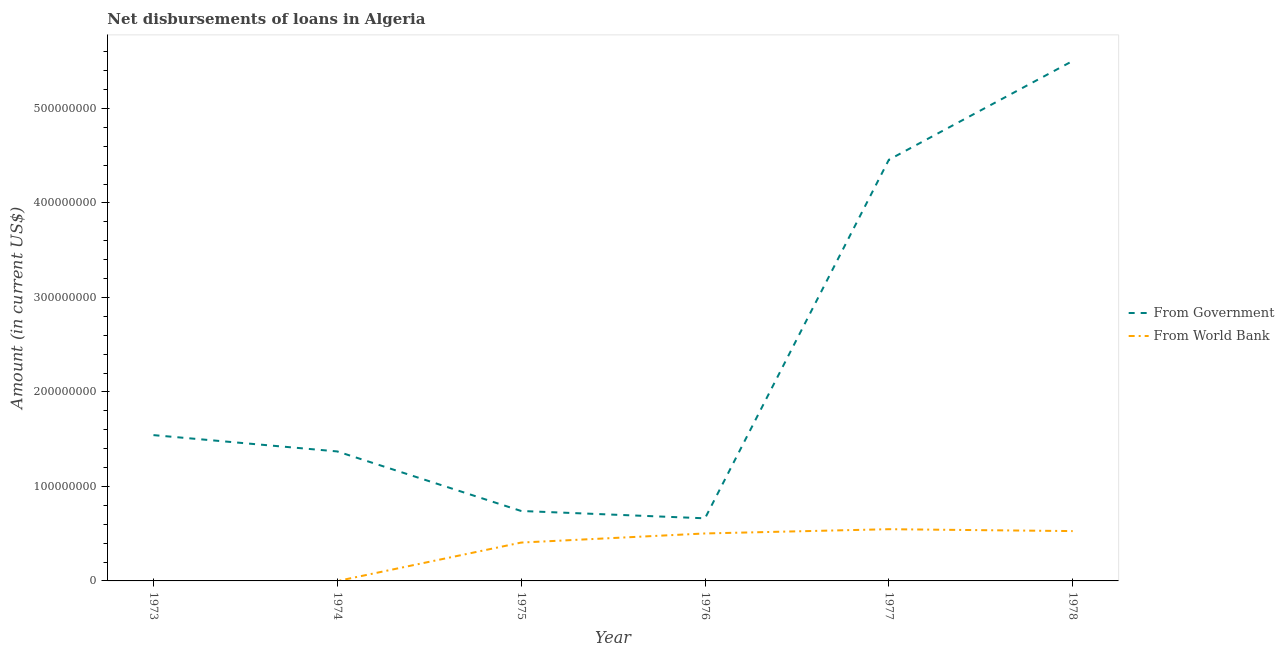How many different coloured lines are there?
Your answer should be very brief. 2. Is the number of lines equal to the number of legend labels?
Your response must be concise. No. What is the net disbursements of loan from world bank in 1976?
Keep it short and to the point. 5.02e+07. Across all years, what is the maximum net disbursements of loan from world bank?
Your response must be concise. 5.47e+07. Across all years, what is the minimum net disbursements of loan from world bank?
Offer a terse response. 0. What is the total net disbursements of loan from world bank in the graph?
Your response must be concise. 1.98e+08. What is the difference between the net disbursements of loan from government in 1973 and that in 1974?
Offer a terse response. 1.73e+07. What is the difference between the net disbursements of loan from government in 1975 and the net disbursements of loan from world bank in 1978?
Give a very brief answer. 2.13e+07. What is the average net disbursements of loan from world bank per year?
Offer a terse response. 3.30e+07. In the year 1975, what is the difference between the net disbursements of loan from government and net disbursements of loan from world bank?
Give a very brief answer. 3.34e+07. In how many years, is the net disbursements of loan from world bank greater than 360000000 US$?
Make the answer very short. 0. What is the ratio of the net disbursements of loan from world bank in 1975 to that in 1978?
Your response must be concise. 0.77. Is the net disbursements of loan from government in 1973 less than that in 1974?
Ensure brevity in your answer.  No. What is the difference between the highest and the second highest net disbursements of loan from world bank?
Make the answer very short. 2.00e+06. What is the difference between the highest and the lowest net disbursements of loan from government?
Your answer should be very brief. 4.84e+08. In how many years, is the net disbursements of loan from world bank greater than the average net disbursements of loan from world bank taken over all years?
Offer a very short reply. 4. Does the net disbursements of loan from world bank monotonically increase over the years?
Offer a terse response. No. Is the net disbursements of loan from world bank strictly greater than the net disbursements of loan from government over the years?
Your answer should be compact. No. Is the net disbursements of loan from government strictly less than the net disbursements of loan from world bank over the years?
Give a very brief answer. No. Are the values on the major ticks of Y-axis written in scientific E-notation?
Make the answer very short. No. Does the graph contain any zero values?
Your answer should be very brief. Yes. How many legend labels are there?
Your response must be concise. 2. What is the title of the graph?
Offer a terse response. Net disbursements of loans in Algeria. Does "Health Care" appear as one of the legend labels in the graph?
Offer a terse response. No. What is the Amount (in current US$) of From Government in 1973?
Give a very brief answer. 1.54e+08. What is the Amount (in current US$) of From World Bank in 1973?
Keep it short and to the point. 0. What is the Amount (in current US$) in From Government in 1974?
Offer a very short reply. 1.37e+08. What is the Amount (in current US$) of From Government in 1975?
Provide a short and direct response. 7.40e+07. What is the Amount (in current US$) in From World Bank in 1975?
Keep it short and to the point. 4.06e+07. What is the Amount (in current US$) of From Government in 1976?
Your answer should be very brief. 6.63e+07. What is the Amount (in current US$) in From World Bank in 1976?
Your response must be concise. 5.02e+07. What is the Amount (in current US$) in From Government in 1977?
Offer a very short reply. 4.46e+08. What is the Amount (in current US$) of From World Bank in 1977?
Give a very brief answer. 5.47e+07. What is the Amount (in current US$) in From Government in 1978?
Make the answer very short. 5.50e+08. What is the Amount (in current US$) in From World Bank in 1978?
Provide a short and direct response. 5.27e+07. Across all years, what is the maximum Amount (in current US$) in From Government?
Offer a very short reply. 5.50e+08. Across all years, what is the maximum Amount (in current US$) in From World Bank?
Offer a terse response. 5.47e+07. Across all years, what is the minimum Amount (in current US$) of From Government?
Keep it short and to the point. 6.63e+07. What is the total Amount (in current US$) in From Government in the graph?
Offer a terse response. 1.43e+09. What is the total Amount (in current US$) of From World Bank in the graph?
Offer a very short reply. 1.98e+08. What is the difference between the Amount (in current US$) in From Government in 1973 and that in 1974?
Offer a very short reply. 1.73e+07. What is the difference between the Amount (in current US$) of From Government in 1973 and that in 1975?
Your response must be concise. 8.03e+07. What is the difference between the Amount (in current US$) in From Government in 1973 and that in 1976?
Offer a terse response. 8.80e+07. What is the difference between the Amount (in current US$) in From Government in 1973 and that in 1977?
Offer a terse response. -2.91e+08. What is the difference between the Amount (in current US$) of From Government in 1973 and that in 1978?
Provide a succinct answer. -3.96e+08. What is the difference between the Amount (in current US$) in From Government in 1974 and that in 1975?
Your response must be concise. 6.30e+07. What is the difference between the Amount (in current US$) in From Government in 1974 and that in 1976?
Your answer should be very brief. 7.08e+07. What is the difference between the Amount (in current US$) of From Government in 1974 and that in 1977?
Keep it short and to the point. -3.09e+08. What is the difference between the Amount (in current US$) of From Government in 1974 and that in 1978?
Provide a short and direct response. -4.13e+08. What is the difference between the Amount (in current US$) of From Government in 1975 and that in 1976?
Keep it short and to the point. 7.76e+06. What is the difference between the Amount (in current US$) in From World Bank in 1975 and that in 1976?
Ensure brevity in your answer.  -9.64e+06. What is the difference between the Amount (in current US$) in From Government in 1975 and that in 1977?
Your answer should be compact. -3.72e+08. What is the difference between the Amount (in current US$) of From World Bank in 1975 and that in 1977?
Ensure brevity in your answer.  -1.41e+07. What is the difference between the Amount (in current US$) of From Government in 1975 and that in 1978?
Provide a succinct answer. -4.76e+08. What is the difference between the Amount (in current US$) of From World Bank in 1975 and that in 1978?
Give a very brief answer. -1.21e+07. What is the difference between the Amount (in current US$) of From Government in 1976 and that in 1977?
Offer a very short reply. -3.79e+08. What is the difference between the Amount (in current US$) of From World Bank in 1976 and that in 1977?
Keep it short and to the point. -4.50e+06. What is the difference between the Amount (in current US$) of From Government in 1976 and that in 1978?
Your answer should be very brief. -4.84e+08. What is the difference between the Amount (in current US$) in From World Bank in 1976 and that in 1978?
Your answer should be very brief. -2.50e+06. What is the difference between the Amount (in current US$) of From Government in 1977 and that in 1978?
Make the answer very short. -1.05e+08. What is the difference between the Amount (in current US$) in From World Bank in 1977 and that in 1978?
Provide a short and direct response. 2.00e+06. What is the difference between the Amount (in current US$) in From Government in 1973 and the Amount (in current US$) in From World Bank in 1975?
Make the answer very short. 1.14e+08. What is the difference between the Amount (in current US$) in From Government in 1973 and the Amount (in current US$) in From World Bank in 1976?
Your response must be concise. 1.04e+08. What is the difference between the Amount (in current US$) of From Government in 1973 and the Amount (in current US$) of From World Bank in 1977?
Make the answer very short. 9.96e+07. What is the difference between the Amount (in current US$) of From Government in 1973 and the Amount (in current US$) of From World Bank in 1978?
Make the answer very short. 1.02e+08. What is the difference between the Amount (in current US$) of From Government in 1974 and the Amount (in current US$) of From World Bank in 1975?
Provide a succinct answer. 9.64e+07. What is the difference between the Amount (in current US$) of From Government in 1974 and the Amount (in current US$) of From World Bank in 1976?
Provide a succinct answer. 8.68e+07. What is the difference between the Amount (in current US$) of From Government in 1974 and the Amount (in current US$) of From World Bank in 1977?
Provide a succinct answer. 8.23e+07. What is the difference between the Amount (in current US$) in From Government in 1974 and the Amount (in current US$) in From World Bank in 1978?
Your answer should be very brief. 8.43e+07. What is the difference between the Amount (in current US$) of From Government in 1975 and the Amount (in current US$) of From World Bank in 1976?
Make the answer very short. 2.38e+07. What is the difference between the Amount (in current US$) of From Government in 1975 and the Amount (in current US$) of From World Bank in 1977?
Your answer should be very brief. 1.93e+07. What is the difference between the Amount (in current US$) of From Government in 1975 and the Amount (in current US$) of From World Bank in 1978?
Your answer should be very brief. 2.13e+07. What is the difference between the Amount (in current US$) of From Government in 1976 and the Amount (in current US$) of From World Bank in 1977?
Your response must be concise. 1.15e+07. What is the difference between the Amount (in current US$) in From Government in 1976 and the Amount (in current US$) in From World Bank in 1978?
Provide a succinct answer. 1.35e+07. What is the difference between the Amount (in current US$) in From Government in 1977 and the Amount (in current US$) in From World Bank in 1978?
Provide a succinct answer. 3.93e+08. What is the average Amount (in current US$) of From Government per year?
Provide a succinct answer. 2.38e+08. What is the average Amount (in current US$) of From World Bank per year?
Your answer should be compact. 3.30e+07. In the year 1975, what is the difference between the Amount (in current US$) of From Government and Amount (in current US$) of From World Bank?
Ensure brevity in your answer.  3.34e+07. In the year 1976, what is the difference between the Amount (in current US$) in From Government and Amount (in current US$) in From World Bank?
Provide a succinct answer. 1.60e+07. In the year 1977, what is the difference between the Amount (in current US$) of From Government and Amount (in current US$) of From World Bank?
Provide a short and direct response. 3.91e+08. In the year 1978, what is the difference between the Amount (in current US$) of From Government and Amount (in current US$) of From World Bank?
Your response must be concise. 4.98e+08. What is the ratio of the Amount (in current US$) of From Government in 1973 to that in 1974?
Your answer should be very brief. 1.13. What is the ratio of the Amount (in current US$) in From Government in 1973 to that in 1975?
Your answer should be compact. 2.08. What is the ratio of the Amount (in current US$) of From Government in 1973 to that in 1976?
Keep it short and to the point. 2.33. What is the ratio of the Amount (in current US$) in From Government in 1973 to that in 1977?
Offer a terse response. 0.35. What is the ratio of the Amount (in current US$) in From Government in 1973 to that in 1978?
Your response must be concise. 0.28. What is the ratio of the Amount (in current US$) in From Government in 1974 to that in 1975?
Your answer should be compact. 1.85. What is the ratio of the Amount (in current US$) in From Government in 1974 to that in 1976?
Your answer should be very brief. 2.07. What is the ratio of the Amount (in current US$) in From Government in 1974 to that in 1977?
Your answer should be compact. 0.31. What is the ratio of the Amount (in current US$) in From Government in 1974 to that in 1978?
Offer a very short reply. 0.25. What is the ratio of the Amount (in current US$) in From Government in 1975 to that in 1976?
Offer a very short reply. 1.12. What is the ratio of the Amount (in current US$) in From World Bank in 1975 to that in 1976?
Keep it short and to the point. 0.81. What is the ratio of the Amount (in current US$) of From Government in 1975 to that in 1977?
Your answer should be compact. 0.17. What is the ratio of the Amount (in current US$) in From World Bank in 1975 to that in 1977?
Offer a very short reply. 0.74. What is the ratio of the Amount (in current US$) of From Government in 1975 to that in 1978?
Your answer should be very brief. 0.13. What is the ratio of the Amount (in current US$) of From World Bank in 1975 to that in 1978?
Your answer should be compact. 0.77. What is the ratio of the Amount (in current US$) in From Government in 1976 to that in 1977?
Keep it short and to the point. 0.15. What is the ratio of the Amount (in current US$) in From World Bank in 1976 to that in 1977?
Give a very brief answer. 0.92. What is the ratio of the Amount (in current US$) in From Government in 1976 to that in 1978?
Ensure brevity in your answer.  0.12. What is the ratio of the Amount (in current US$) in From World Bank in 1976 to that in 1978?
Your response must be concise. 0.95. What is the ratio of the Amount (in current US$) of From Government in 1977 to that in 1978?
Provide a succinct answer. 0.81. What is the ratio of the Amount (in current US$) in From World Bank in 1977 to that in 1978?
Offer a very short reply. 1.04. What is the difference between the highest and the second highest Amount (in current US$) of From Government?
Offer a terse response. 1.05e+08. What is the difference between the highest and the second highest Amount (in current US$) of From World Bank?
Make the answer very short. 2.00e+06. What is the difference between the highest and the lowest Amount (in current US$) in From Government?
Offer a very short reply. 4.84e+08. What is the difference between the highest and the lowest Amount (in current US$) of From World Bank?
Ensure brevity in your answer.  5.47e+07. 